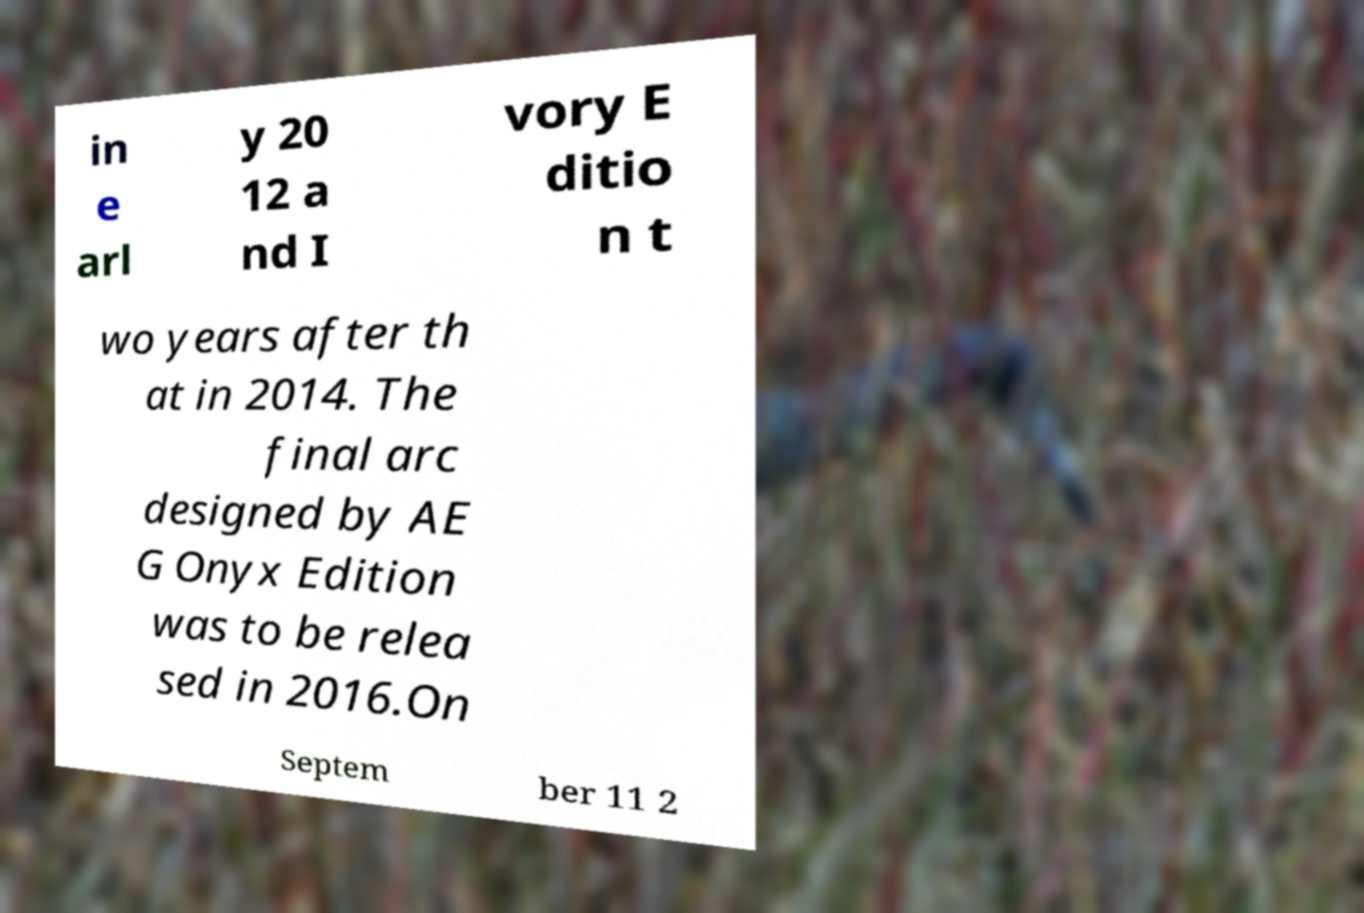Could you assist in decoding the text presented in this image and type it out clearly? in e arl y 20 12 a nd I vory E ditio n t wo years after th at in 2014. The final arc designed by AE G Onyx Edition was to be relea sed in 2016.On Septem ber 11 2 